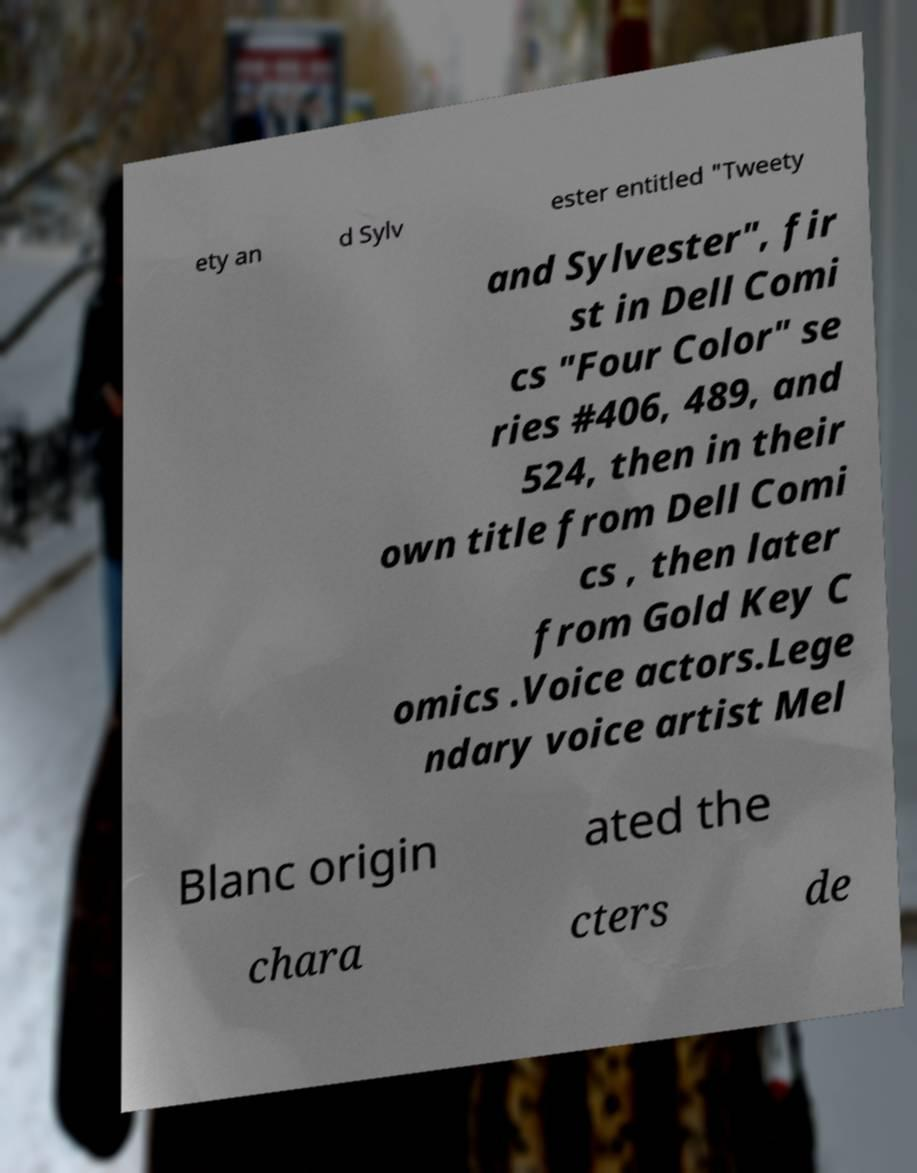Could you extract and type out the text from this image? ety an d Sylv ester entitled "Tweety and Sylvester", fir st in Dell Comi cs "Four Color" se ries #406, 489, and 524, then in their own title from Dell Comi cs , then later from Gold Key C omics .Voice actors.Lege ndary voice artist Mel Blanc origin ated the chara cters de 